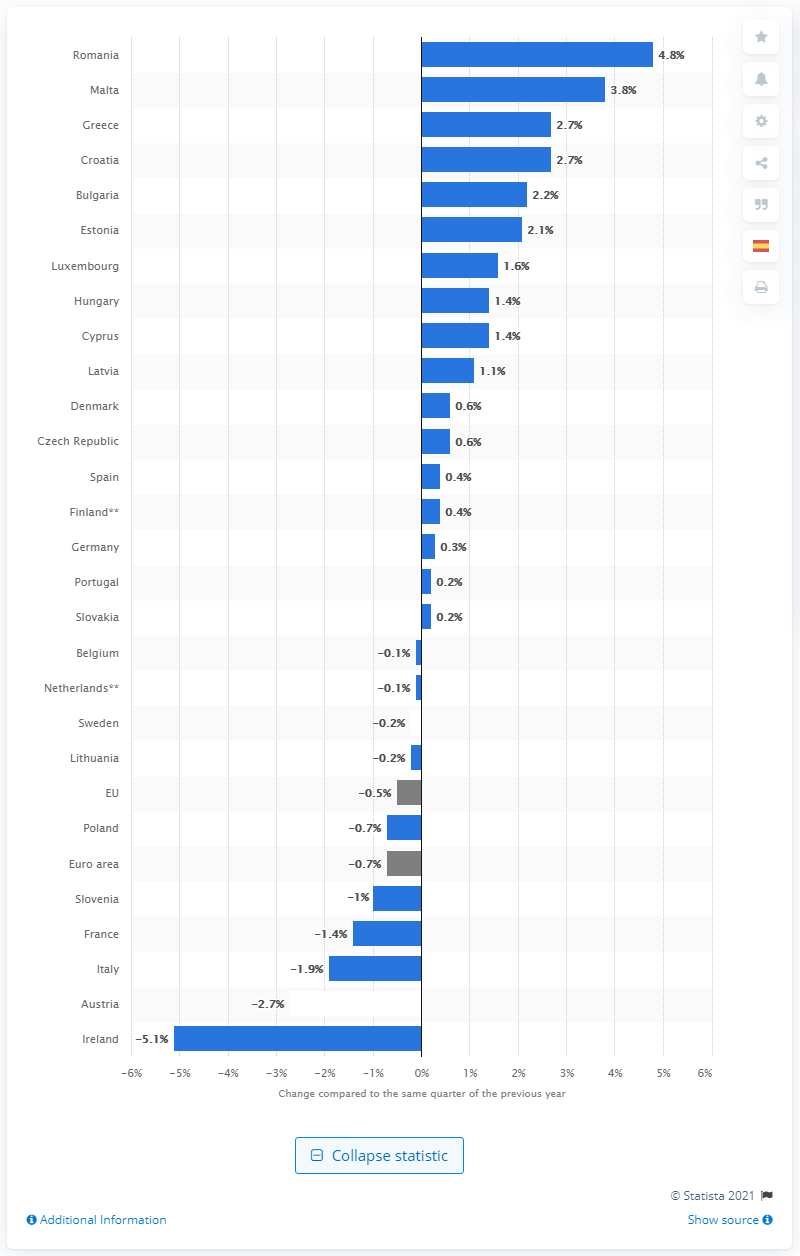Draw attention to some important aspects in this diagram. Denmark's Gross Domestic Product (GDP) increased by 0.6% in the fourth quarter of 2020. 